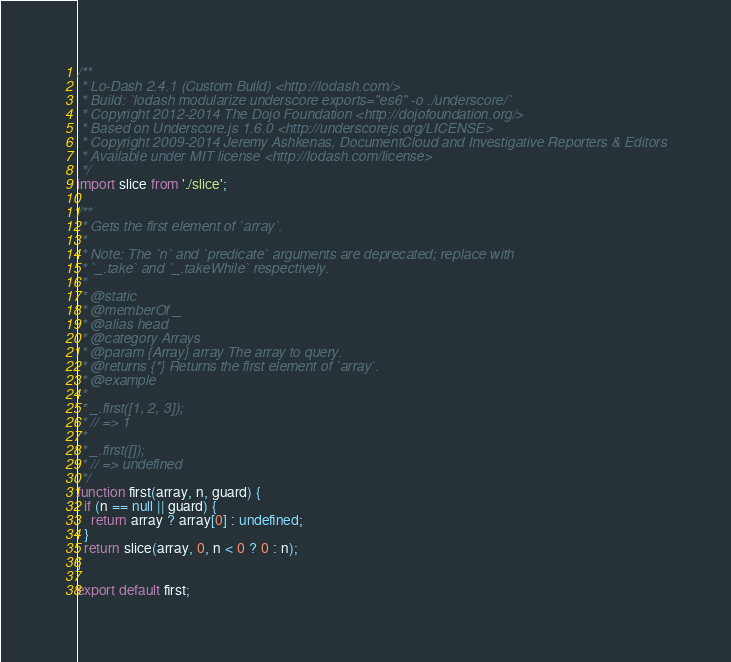<code> <loc_0><loc_0><loc_500><loc_500><_JavaScript_>/**
 * Lo-Dash 2.4.1 (Custom Build) <http://lodash.com/>
 * Build: `lodash modularize underscore exports="es6" -o ./underscore/`
 * Copyright 2012-2014 The Dojo Foundation <http://dojofoundation.org/>
 * Based on Underscore.js 1.6.0 <http://underscorejs.org/LICENSE>
 * Copyright 2009-2014 Jeremy Ashkenas, DocumentCloud and Investigative Reporters & Editors
 * Available under MIT license <http://lodash.com/license>
 */
import slice from './slice';

/**
 * Gets the first element of `array`.
 *
 * Note: The `n` and `predicate` arguments are deprecated; replace with
 * `_.take` and `_.takeWhile` respectively.
 *
 * @static
 * @memberOf _
 * @alias head
 * @category Arrays
 * @param {Array} array The array to query.
 * @returns {*} Returns the first element of `array`.
 * @example
 *
 * _.first([1, 2, 3]);
 * // => 1
 *
 * _.first([]);
 * // => undefined
 */
function first(array, n, guard) {
  if (n == null || guard) {
    return array ? array[0] : undefined;
  }
  return slice(array, 0, n < 0 ? 0 : n);
}

export default first;
</code> 